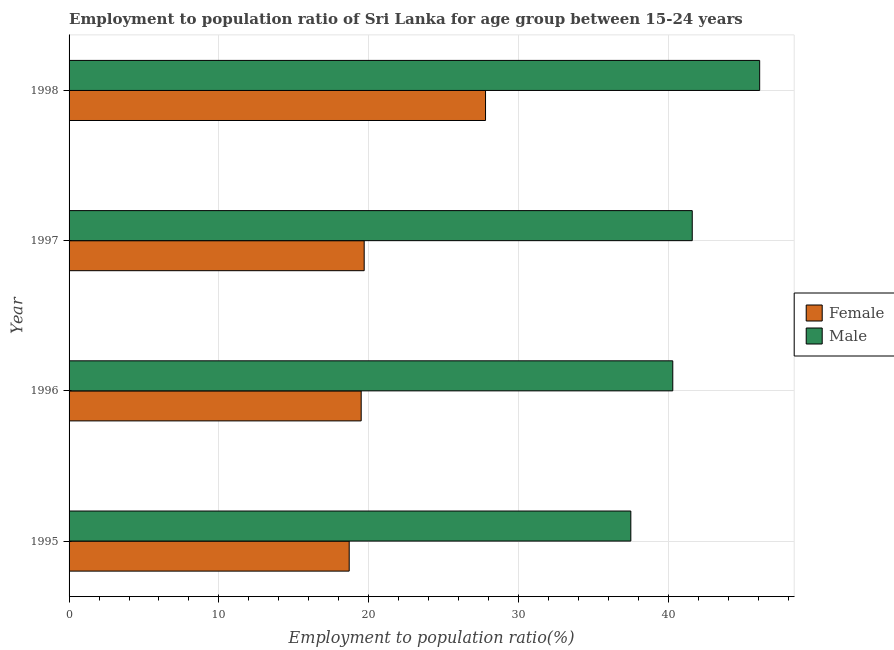How many different coloured bars are there?
Your answer should be very brief. 2. Are the number of bars per tick equal to the number of legend labels?
Provide a succinct answer. Yes. Are the number of bars on each tick of the Y-axis equal?
Give a very brief answer. Yes. How many bars are there on the 4th tick from the bottom?
Provide a succinct answer. 2. What is the label of the 1st group of bars from the top?
Offer a very short reply. 1998. In how many cases, is the number of bars for a given year not equal to the number of legend labels?
Offer a terse response. 0. Across all years, what is the maximum employment to population ratio(female)?
Keep it short and to the point. 27.8. Across all years, what is the minimum employment to population ratio(male)?
Offer a very short reply. 37.5. In which year was the employment to population ratio(female) maximum?
Your response must be concise. 1998. What is the total employment to population ratio(female) in the graph?
Offer a very short reply. 85.7. What is the difference between the employment to population ratio(male) in 1997 and the employment to population ratio(female) in 1996?
Offer a terse response. 22.1. What is the average employment to population ratio(male) per year?
Give a very brief answer. 41.38. In the year 1996, what is the difference between the employment to population ratio(female) and employment to population ratio(male)?
Offer a very short reply. -20.8. What is the ratio of the employment to population ratio(female) in 1996 to that in 1997?
Keep it short and to the point. 0.99. Is the employment to population ratio(female) in 1997 less than that in 1998?
Offer a very short reply. Yes. Is the difference between the employment to population ratio(female) in 1995 and 1996 greater than the difference between the employment to population ratio(male) in 1995 and 1996?
Make the answer very short. Yes. What is the difference between the highest and the lowest employment to population ratio(female)?
Your response must be concise. 9.1. In how many years, is the employment to population ratio(female) greater than the average employment to population ratio(female) taken over all years?
Offer a very short reply. 1. What does the 2nd bar from the top in 1998 represents?
Ensure brevity in your answer.  Female. What does the 2nd bar from the bottom in 1998 represents?
Provide a short and direct response. Male. How many years are there in the graph?
Ensure brevity in your answer.  4. What is the title of the graph?
Provide a short and direct response. Employment to population ratio of Sri Lanka for age group between 15-24 years. What is the label or title of the X-axis?
Make the answer very short. Employment to population ratio(%). What is the Employment to population ratio(%) of Female in 1995?
Provide a short and direct response. 18.7. What is the Employment to population ratio(%) of Male in 1995?
Keep it short and to the point. 37.5. What is the Employment to population ratio(%) in Male in 1996?
Offer a terse response. 40.3. What is the Employment to population ratio(%) in Female in 1997?
Offer a terse response. 19.7. What is the Employment to population ratio(%) in Male in 1997?
Your response must be concise. 41.6. What is the Employment to population ratio(%) of Female in 1998?
Your answer should be compact. 27.8. What is the Employment to population ratio(%) in Male in 1998?
Your answer should be compact. 46.1. Across all years, what is the maximum Employment to population ratio(%) in Female?
Your answer should be very brief. 27.8. Across all years, what is the maximum Employment to population ratio(%) of Male?
Your answer should be very brief. 46.1. Across all years, what is the minimum Employment to population ratio(%) in Female?
Keep it short and to the point. 18.7. Across all years, what is the minimum Employment to population ratio(%) in Male?
Ensure brevity in your answer.  37.5. What is the total Employment to population ratio(%) of Female in the graph?
Your answer should be very brief. 85.7. What is the total Employment to population ratio(%) in Male in the graph?
Offer a terse response. 165.5. What is the difference between the Employment to population ratio(%) of Male in 1995 and that in 1996?
Keep it short and to the point. -2.8. What is the difference between the Employment to population ratio(%) of Female in 1995 and that in 1997?
Keep it short and to the point. -1. What is the difference between the Employment to population ratio(%) in Female in 1995 and that in 1998?
Offer a terse response. -9.1. What is the difference between the Employment to population ratio(%) of Male in 1996 and that in 1997?
Your response must be concise. -1.3. What is the difference between the Employment to population ratio(%) of Male in 1996 and that in 1998?
Provide a short and direct response. -5.8. What is the difference between the Employment to population ratio(%) in Female in 1997 and that in 1998?
Provide a short and direct response. -8.1. What is the difference between the Employment to population ratio(%) in Male in 1997 and that in 1998?
Ensure brevity in your answer.  -4.5. What is the difference between the Employment to population ratio(%) of Female in 1995 and the Employment to population ratio(%) of Male in 1996?
Ensure brevity in your answer.  -21.6. What is the difference between the Employment to population ratio(%) in Female in 1995 and the Employment to population ratio(%) in Male in 1997?
Your response must be concise. -22.9. What is the difference between the Employment to population ratio(%) of Female in 1995 and the Employment to population ratio(%) of Male in 1998?
Your answer should be compact. -27.4. What is the difference between the Employment to population ratio(%) in Female in 1996 and the Employment to population ratio(%) in Male in 1997?
Provide a succinct answer. -22.1. What is the difference between the Employment to population ratio(%) in Female in 1996 and the Employment to population ratio(%) in Male in 1998?
Give a very brief answer. -26.6. What is the difference between the Employment to population ratio(%) of Female in 1997 and the Employment to population ratio(%) of Male in 1998?
Provide a succinct answer. -26.4. What is the average Employment to population ratio(%) in Female per year?
Provide a succinct answer. 21.43. What is the average Employment to population ratio(%) of Male per year?
Give a very brief answer. 41.38. In the year 1995, what is the difference between the Employment to population ratio(%) of Female and Employment to population ratio(%) of Male?
Give a very brief answer. -18.8. In the year 1996, what is the difference between the Employment to population ratio(%) in Female and Employment to population ratio(%) in Male?
Your answer should be compact. -20.8. In the year 1997, what is the difference between the Employment to population ratio(%) in Female and Employment to population ratio(%) in Male?
Provide a succinct answer. -21.9. In the year 1998, what is the difference between the Employment to population ratio(%) in Female and Employment to population ratio(%) in Male?
Make the answer very short. -18.3. What is the ratio of the Employment to population ratio(%) of Male in 1995 to that in 1996?
Offer a terse response. 0.93. What is the ratio of the Employment to population ratio(%) in Female in 1995 to that in 1997?
Ensure brevity in your answer.  0.95. What is the ratio of the Employment to population ratio(%) in Male in 1995 to that in 1997?
Make the answer very short. 0.9. What is the ratio of the Employment to population ratio(%) in Female in 1995 to that in 1998?
Keep it short and to the point. 0.67. What is the ratio of the Employment to population ratio(%) of Male in 1995 to that in 1998?
Keep it short and to the point. 0.81. What is the ratio of the Employment to population ratio(%) of Female in 1996 to that in 1997?
Your answer should be very brief. 0.99. What is the ratio of the Employment to population ratio(%) in Male in 1996 to that in 1997?
Keep it short and to the point. 0.97. What is the ratio of the Employment to population ratio(%) in Female in 1996 to that in 1998?
Offer a terse response. 0.7. What is the ratio of the Employment to population ratio(%) of Male in 1996 to that in 1998?
Give a very brief answer. 0.87. What is the ratio of the Employment to population ratio(%) of Female in 1997 to that in 1998?
Give a very brief answer. 0.71. What is the ratio of the Employment to population ratio(%) in Male in 1997 to that in 1998?
Your response must be concise. 0.9. What is the difference between the highest and the second highest Employment to population ratio(%) of Female?
Your answer should be very brief. 8.1. What is the difference between the highest and the lowest Employment to population ratio(%) in Female?
Make the answer very short. 9.1. 